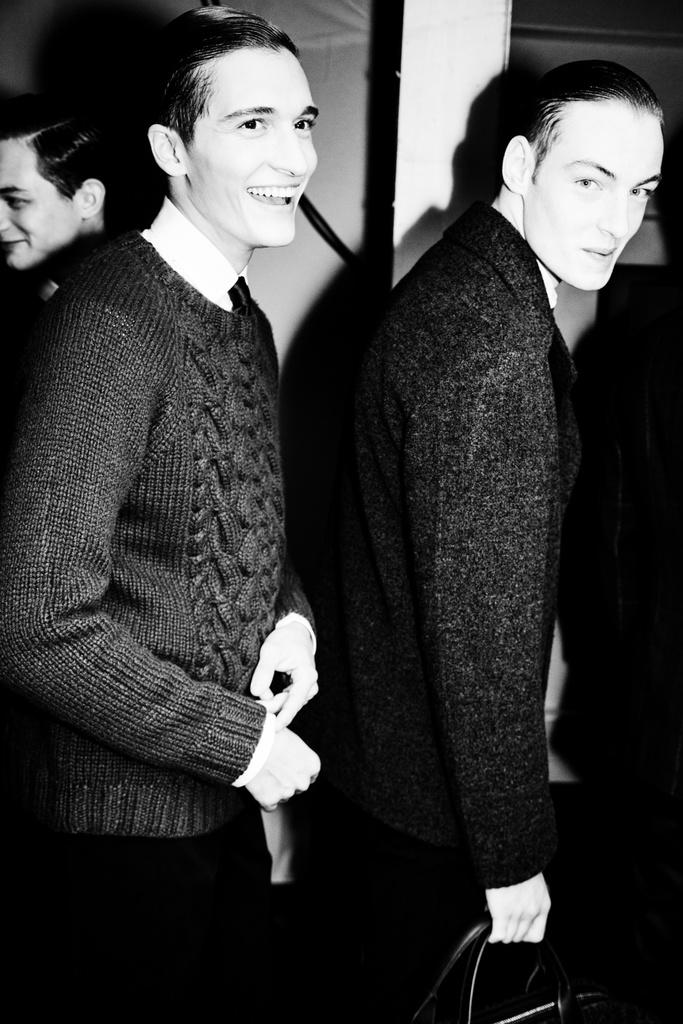How many people are present in the image? There are three men standing in the image. What are the men holding in the image? The men are holding an object. What can be seen towards the top of the image? There are objects visible towards the top of the image, and there is also a wall visible. What type of copper material is used to build the society depicted in the image? There is no mention of copper or a society in the image; it features three men holding an object and other elements visible towards the top. --- Facts: 1. There is a car in the image. 2. The car is parked on the street. 3. There are trees visible in the background. 4. The sky is visible in the background. Absurd Topics: parrot, ocean, volcano Conversation: What is the main subject of the image? The main subject of the image is a car. Where is the car located in the image? The car is parked on the street. What can be seen in the background of the image? There are trees and the sky visible in the background. Reasoning: Let's think step by step in order to produce the conversation. We start by identifying the main subject in the image, which is the car. Then, we describe the car's location, which is parked on the street. Finally, we mention the other elements visible in the background, such as the trees and the sky. Each question is designed to elicit a specific detail about the image that is known from the provided facts. Absurd Question/Answer: Can you see a parrot flying over the ocean near the volcano in the image? There is no parrot, ocean, or volcano present in the image; it features a car parked on the street with trees and the sky visible in the background. 